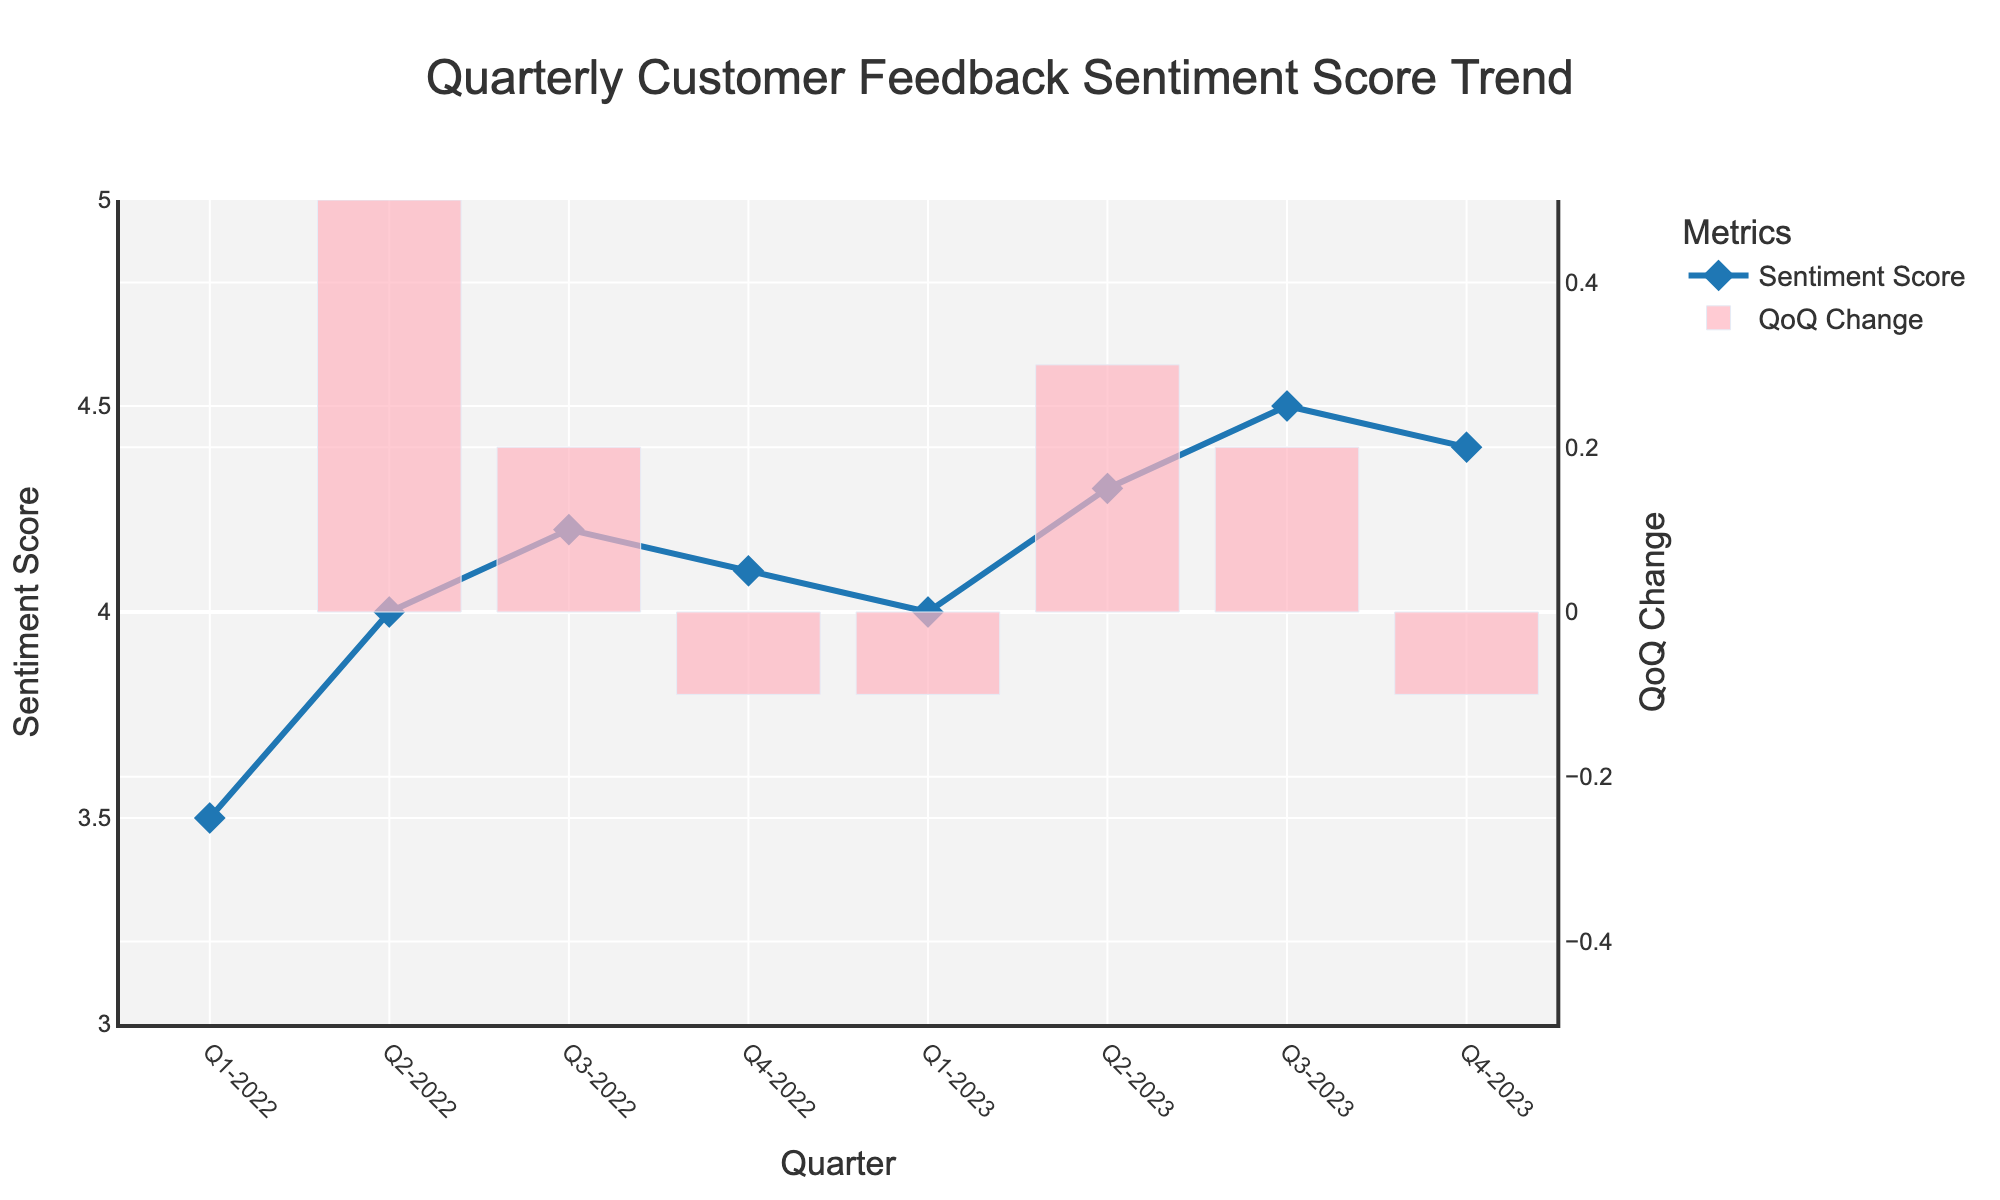what is the trend of the Customer Feedback Sentiment Score over the given quarters? The plot shows a line with markers representing the Customer Feedback Sentiment Score over each quarter. The trend is generally increasing, with a slight fluctuation in the last quarter of 2022.
Answer: Increasing What is the Customer Feedback Sentiment Score for Q3-2023? The line with markers in the plot shows the score for each quarter. For Q3-2023, the marker aligns with a score of 4.5.
Answer: 4.5 Which quarter shows the highest Customer Feedback Sentiment Score? By observing the peaks in the plotted line, Q3-2023 has the highest sentiment score at 4.5.
Answer: Q3-2023 What is the title of the plot? The title is displayed at the top of the plot and reads "Quarterly Customer Feedback Sentiment Score Trend".
Answer: Quarterly Customer Feedback Sentiment Score Trend How many times does the sentiment score decrease from one quarter to the next? By examining the line pattern and identifying decreasing segments, the score decreases twice (Q4-2022 to Q1-2023, and Q3-2023 to Q4-2023).
Answer: 2 What was the quarter-over-quarter change in sentiment score from Q2-2023 to Q3-2023? The bar chart in the plot represents the quarter-over-quarter changes. The bar for Q3-2023 shows an increase of around 0.2.
Answer: About 0.2 Compare the sentiment score changes between Q2-2022 and Q4-2022. Which quarter had a larger increase? By comparing the heights of the bars for Q2-2022 and Q4-2022, Q2-2022 had a larger increase (0.5 vs 0.1).
Answer: Q2-2022 What can be inferred about customer satisfaction in Q4-2023 compared to Q3-2023? From Q3-2023 to Q4-2023, the sentiment score slightly decreased from 4.5 to 4.4, which indicates a minor reduction in customer satisfaction.
Answer: Slight decrease What visual element represents the quarter-over-quarter change in sentiment score? The quarter-over-quarter changes are represented by bars plotted alongside the line chart.
Answer: Bars 